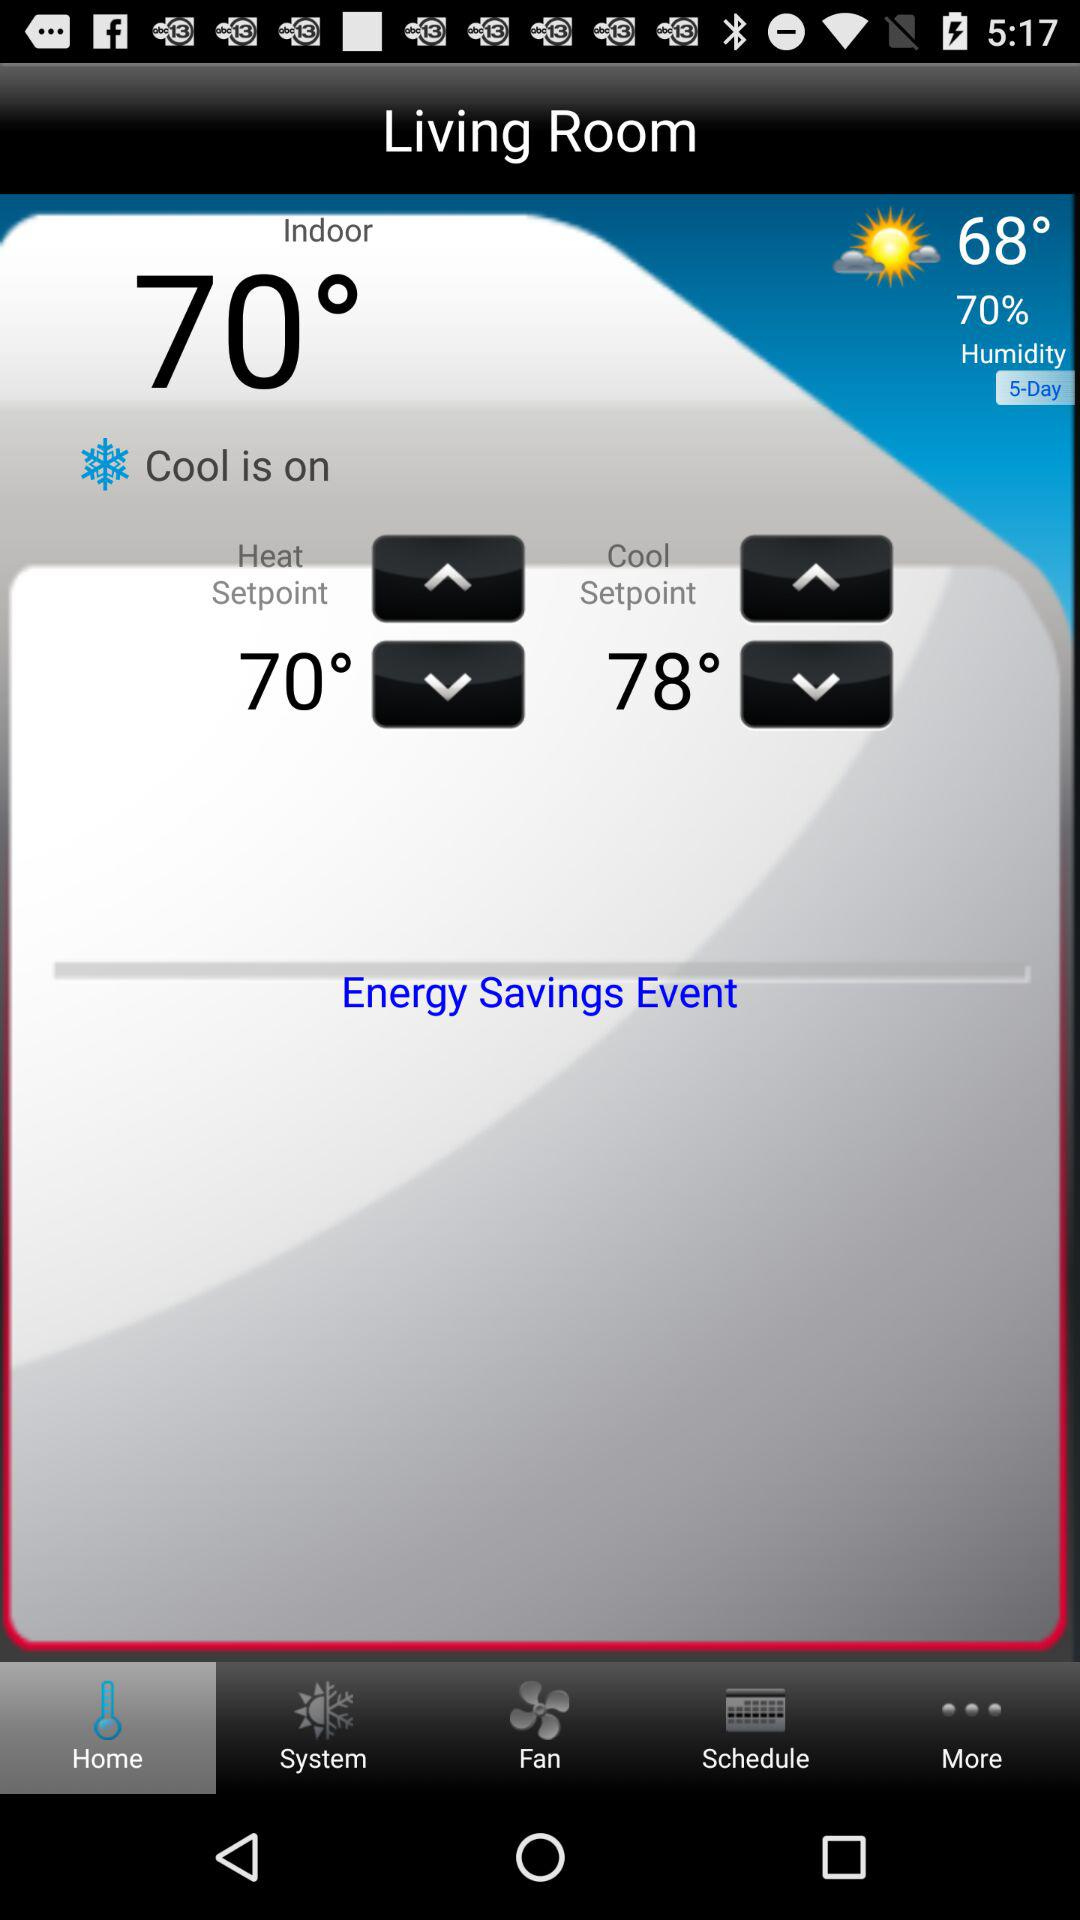What is the humidity? The humidity is 70%. 